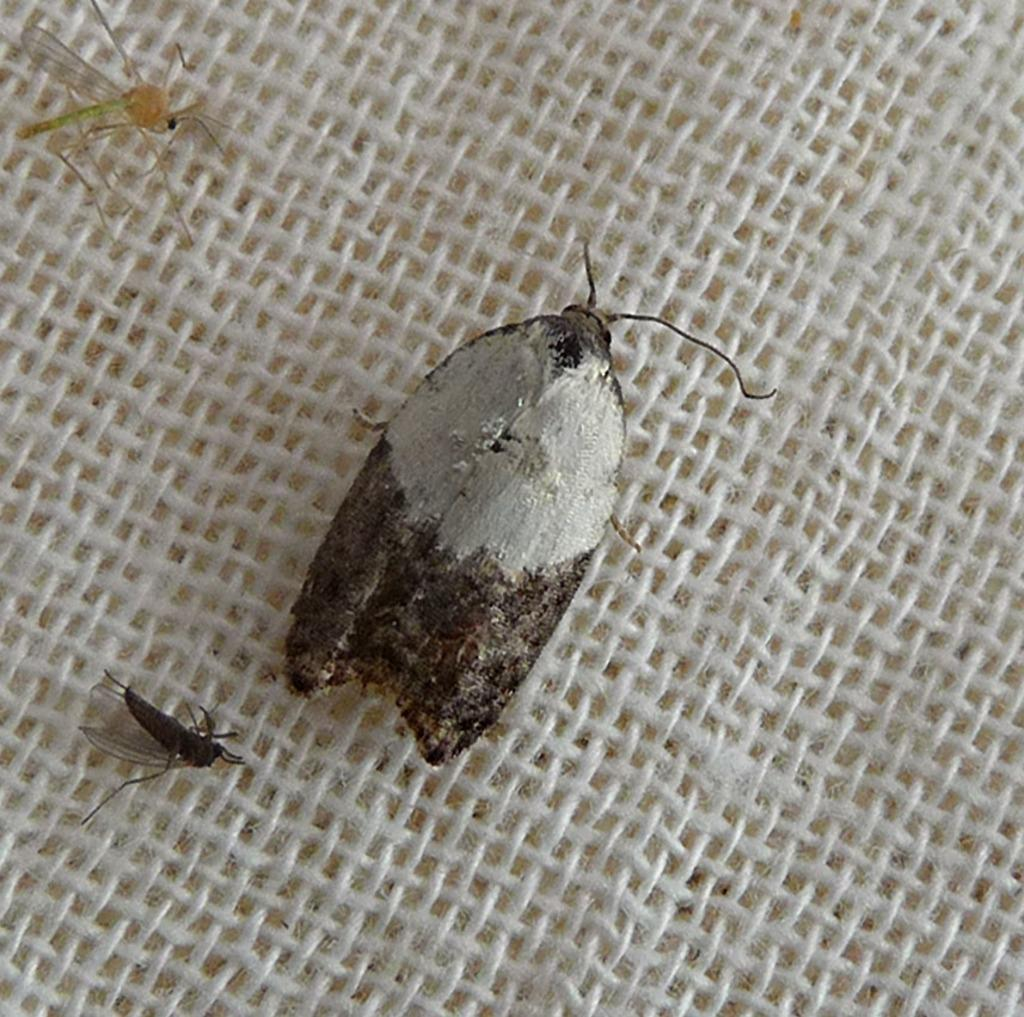What type of material is the cloth in the image made of? The cloth in the image is made of wool. What insects can be seen in the image? There is a fly and two mosquitoes in the image. What type of band is performing in the image? There is no band present in the image; it only features a woolen cloth and insects. 